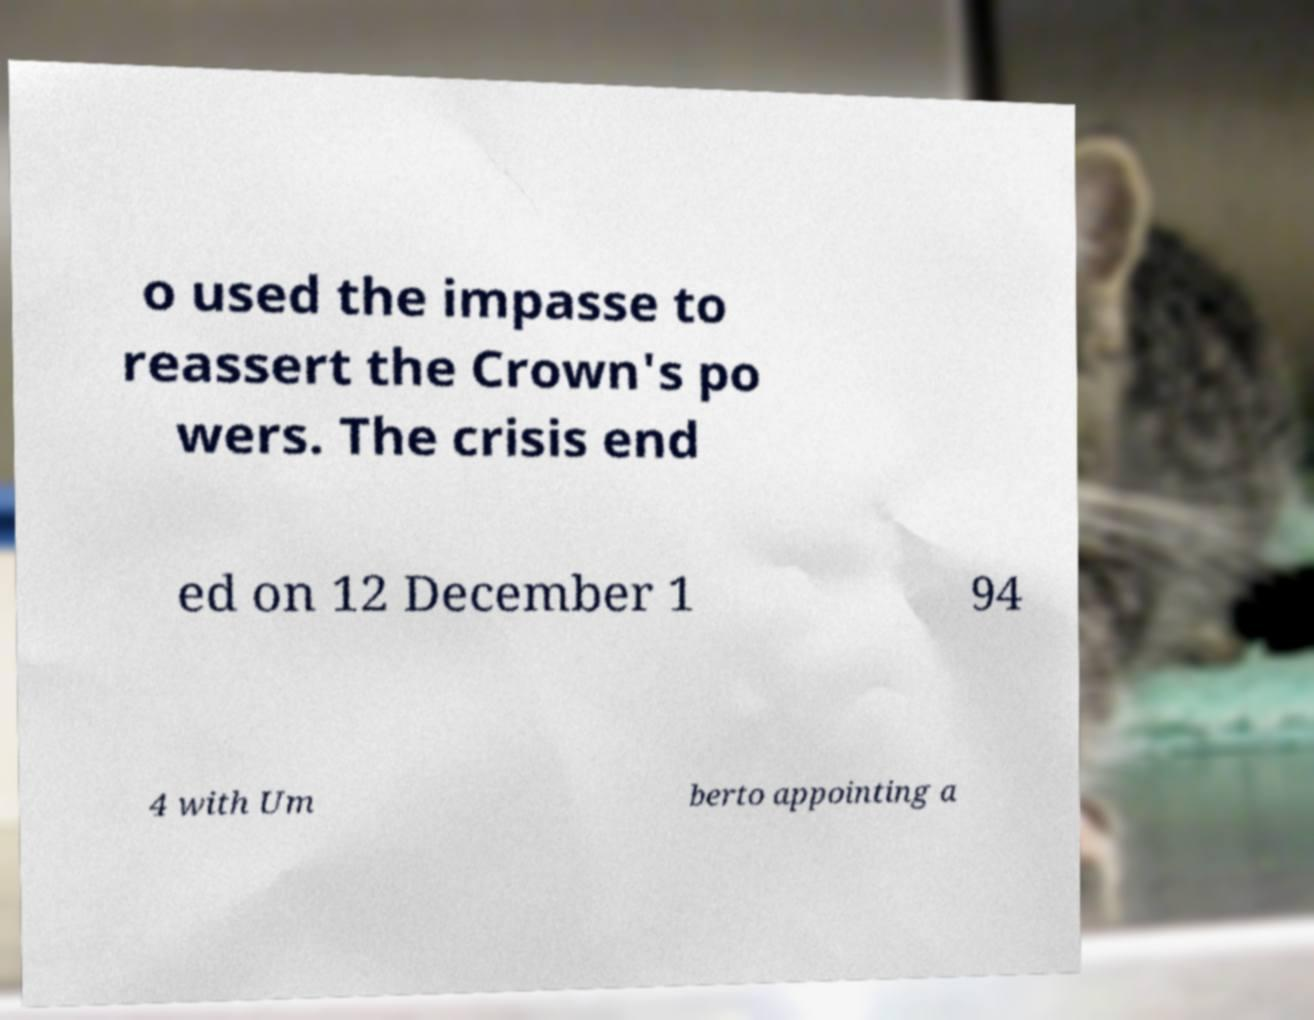Please read and relay the text visible in this image. What does it say? o used the impasse to reassert the Crown's po wers. The crisis end ed on 12 December 1 94 4 with Um berto appointing a 